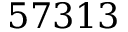<formula> <loc_0><loc_0><loc_500><loc_500>5 7 3 1 3</formula> 